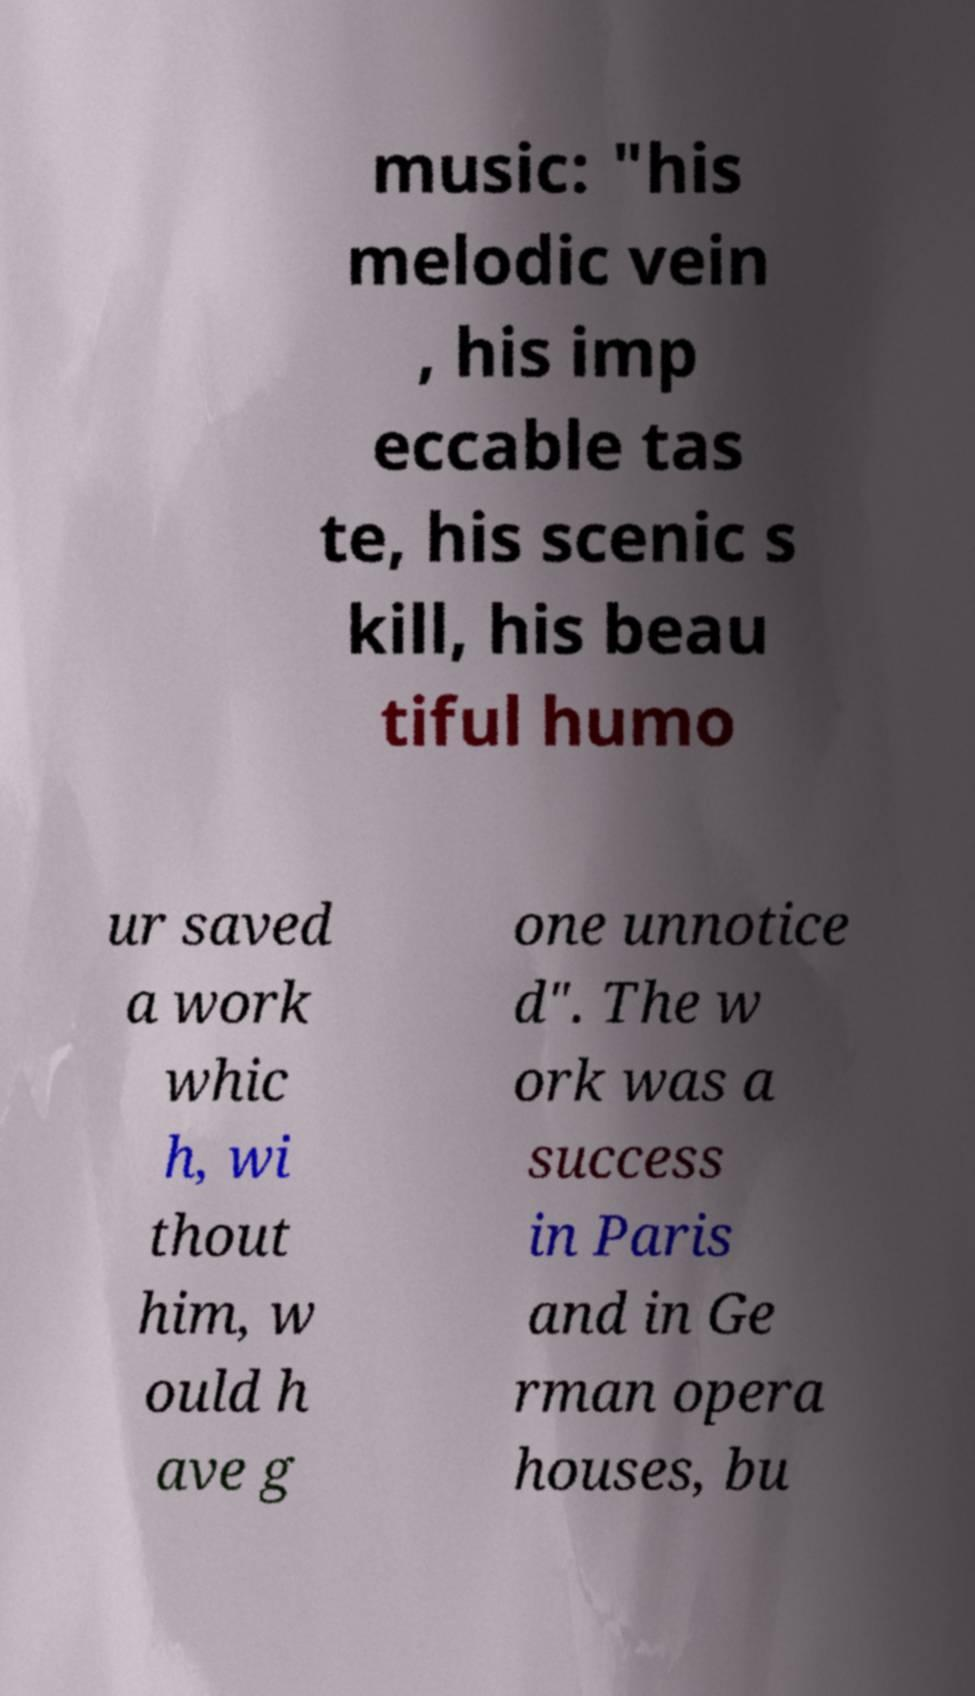Please identify and transcribe the text found in this image. music: "his melodic vein , his imp eccable tas te, his scenic s kill, his beau tiful humo ur saved a work whic h, wi thout him, w ould h ave g one unnotice d". The w ork was a success in Paris and in Ge rman opera houses, bu 